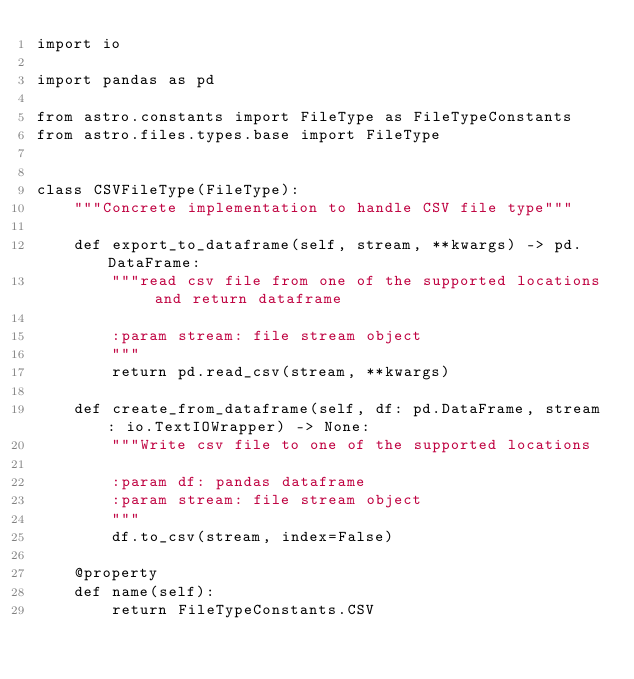<code> <loc_0><loc_0><loc_500><loc_500><_Python_>import io

import pandas as pd

from astro.constants import FileType as FileTypeConstants
from astro.files.types.base import FileType


class CSVFileType(FileType):
    """Concrete implementation to handle CSV file type"""

    def export_to_dataframe(self, stream, **kwargs) -> pd.DataFrame:
        """read csv file from one of the supported locations and return dataframe

        :param stream: file stream object
        """
        return pd.read_csv(stream, **kwargs)

    def create_from_dataframe(self, df: pd.DataFrame, stream: io.TextIOWrapper) -> None:
        """Write csv file to one of the supported locations

        :param df: pandas dataframe
        :param stream: file stream object
        """
        df.to_csv(stream, index=False)

    @property
    def name(self):
        return FileTypeConstants.CSV
</code> 